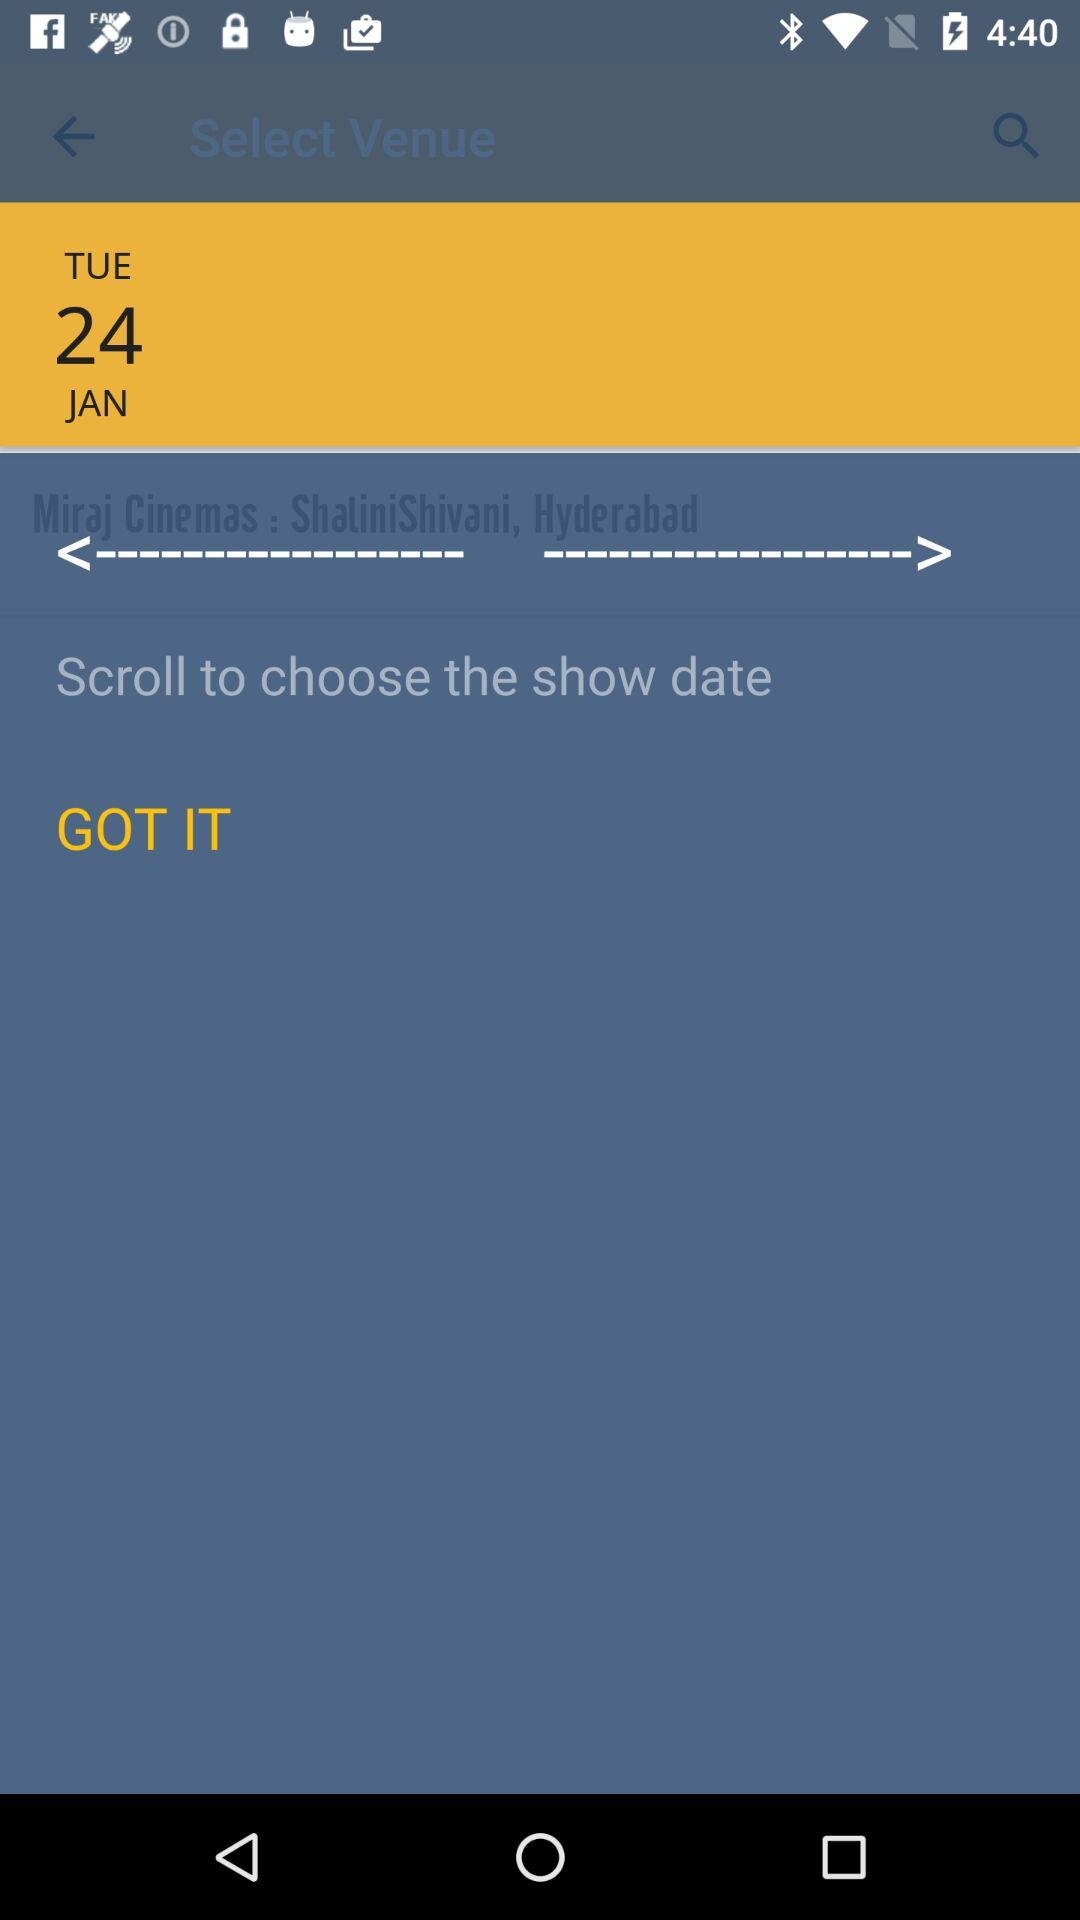Which holiday falls on Tuesday, January 24?
When the provided information is insufficient, respond with <no answer>. <no answer> 